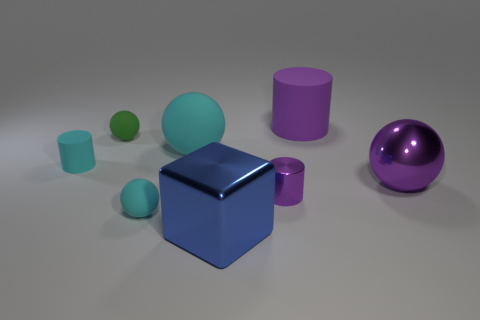What is the composition of the scene in terms of shapes and colors? The scene features a variety of geometric shapes that include spheres, cylinders, and a cube. Color-wise, the image showcases a palette consisting of cyan, green, purple, and a reflective blue cube at the center. The matte and shiny surfaces play with the light, giving a subtle contrast between the objects. 